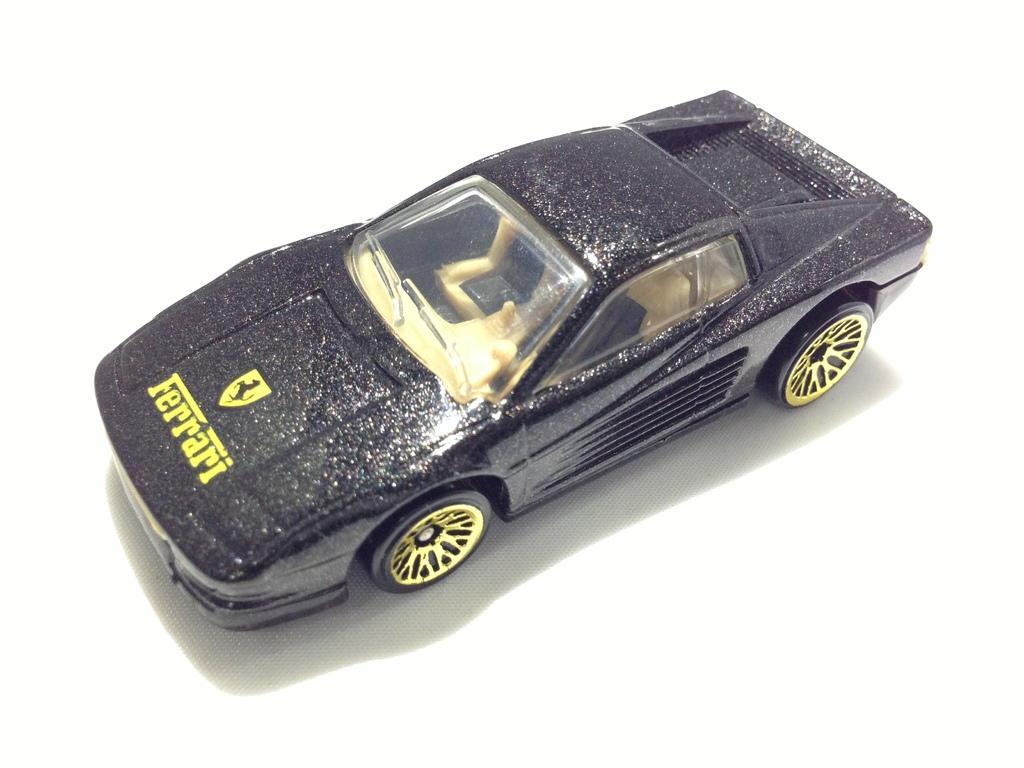Can you describe this image briefly? In this image I can see a toy car which is black and yellow in color is on the white colored surface. 